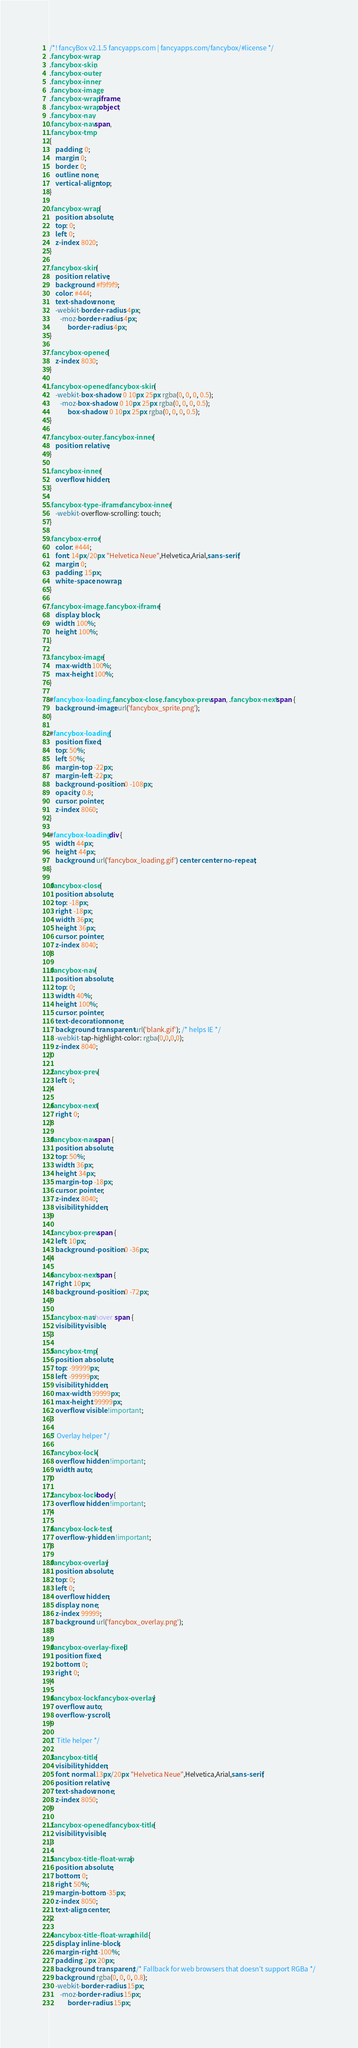<code> <loc_0><loc_0><loc_500><loc_500><_CSS_>/*! fancyBox v2.1.5 fancyapps.com | fancyapps.com/fancybox/#license */
.fancybox-wrap,
.fancybox-skin,
.fancybox-outer,
.fancybox-inner,
.fancybox-image,
.fancybox-wrap iframe,
.fancybox-wrap object,
.fancybox-nav,
.fancybox-nav span,
.fancybox-tmp
{
	padding: 0;
	margin: 0;
	border: 0;
	outline: none;
	vertical-align: top;
}

.fancybox-wrap {
	position: absolute;
	top: 0;
	left: 0;
	z-index: 8020;
}

.fancybox-skin {
	position: relative;
	background: #f9f9f9;
	color: #444;
	text-shadow: none;
	-webkit-border-radius: 4px;
	   -moz-border-radius: 4px;
	        border-radius: 4px;
}

.fancybox-opened {
	z-index: 8030;
}

.fancybox-opened .fancybox-skin {
	-webkit-box-shadow: 0 10px 25px rgba(0, 0, 0, 0.5);
	   -moz-box-shadow: 0 10px 25px rgba(0, 0, 0, 0.5);
	        box-shadow: 0 10px 25px rgba(0, 0, 0, 0.5);
}

.fancybox-outer, .fancybox-inner {
	position: relative;
}

.fancybox-inner {
	overflow: hidden;
}

.fancybox-type-iframe .fancybox-inner {
	-webkit-overflow-scrolling: touch;
}

.fancybox-error {
	color: #444;
	font: 14px/20px "Helvetica Neue",Helvetica,Arial,sans-serif;
	margin: 0;
	padding: 15px;
	white-space: nowrap;
}

.fancybox-image, .fancybox-iframe {
	display: block;
	width: 100%;
	height: 100%;
}

.fancybox-image {
	max-width: 100%;
	max-height: 100%;
}

#fancybox-loading, .fancybox-close, .fancybox-prev span, .fancybox-next span {
	background-image: url('fancybox_sprite.png');
}

#fancybox-loading {
	position: fixed;
	top: 50%;
	left: 50%;
	margin-top: -22px;
	margin-left: -22px;
	background-position: 0 -108px;
	opacity: 0.8;
	cursor: pointer;
	z-index: 8060;
}

#fancybox-loading div {
	width: 44px;
	height: 44px;
	background: url('fancybox_loading.gif') center center no-repeat;
}

.fancybox-close {
	position: absolute;
	top: -18px;
	right: -18px;
	width: 36px;
	height: 36px;
	cursor: pointer;
	z-index: 8040;
}

.fancybox-nav {
	position: absolute;
	top: 0;
	width: 40%;
	height: 100%;
	cursor: pointer;
	text-decoration: none;
	background: transparent url('blank.gif'); /* helps IE */
	-webkit-tap-highlight-color: rgba(0,0,0,0);
	z-index: 8040;
}

.fancybox-prev {
	left: 0;
}

.fancybox-next {
	right: 0;
}

.fancybox-nav span {
	position: absolute;
	top: 50%;
	width: 36px;
	height: 34px;
	margin-top: -18px;
	cursor: pointer;
	z-index: 8040;
	visibility: hidden;
}

.fancybox-prev span {
	left: 10px;
	background-position: 0 -36px;
}

.fancybox-next span {
	right: 10px;
	background-position: 0 -72px;
}

.fancybox-nav:hover span {
	visibility: visible;
}

.fancybox-tmp {
	position: absolute;
	top: -99999px;
	left: -99999px;
	visibility: hidden;
	max-width: 99999px;
	max-height: 99999px;
	overflow: visible !important;
}

/* Overlay helper */

.fancybox-lock {
    overflow: hidden !important;
    width: auto;
}

.fancybox-lock body {
    overflow: hidden !important;
}

.fancybox-lock-test {
    overflow-y: hidden !important;
}

.fancybox-overlay {
	position: absolute;
	top: 0;
	left: 0;
	overflow: hidden;
	display: none;
	z-index: 99999;
	background: url('fancybox_overlay.png');
}

.fancybox-overlay-fixed {
	position: fixed;
	bottom: 0;
	right: 0;
}

.fancybox-lock .fancybox-overlay {
	overflow: auto;
	overflow-y: scroll;
}

/* Title helper */

.fancybox-title {
	visibility: hidden;
	font: normal 13px/20px "Helvetica Neue",Helvetica,Arial,sans-serif;
	position: relative;
	text-shadow: none;
	z-index: 8050;
}

.fancybox-opened .fancybox-title {
	visibility: visible;
}

.fancybox-title-float-wrap {
	position: absolute;
	bottom: 0;
	right: 50%;
	margin-bottom: -35px;
	z-index: 8050;
	text-align: center;
}

.fancybox-title-float-wrap .child {
	display: inline-block;
	margin-right: -100%;
	padding: 2px 20px;
	background: transparent; /* Fallback for web browsers that doesn't support RGBa */
	background: rgba(0, 0, 0, 0.8);
	-webkit-border-radius: 15px;
	   -moz-border-radius: 15px;
	        border-radius: 15px;</code> 